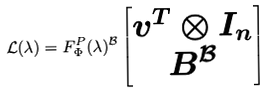<formula> <loc_0><loc_0><loc_500><loc_500>\mathcal { L } ( \lambda ) = F _ { \Phi } ^ { P } ( \lambda ) ^ { \mathcal { B } } \begin{bmatrix} v ^ { T } \otimes I _ { n } \\ B ^ { \mathcal { B } } \end{bmatrix}</formula> 